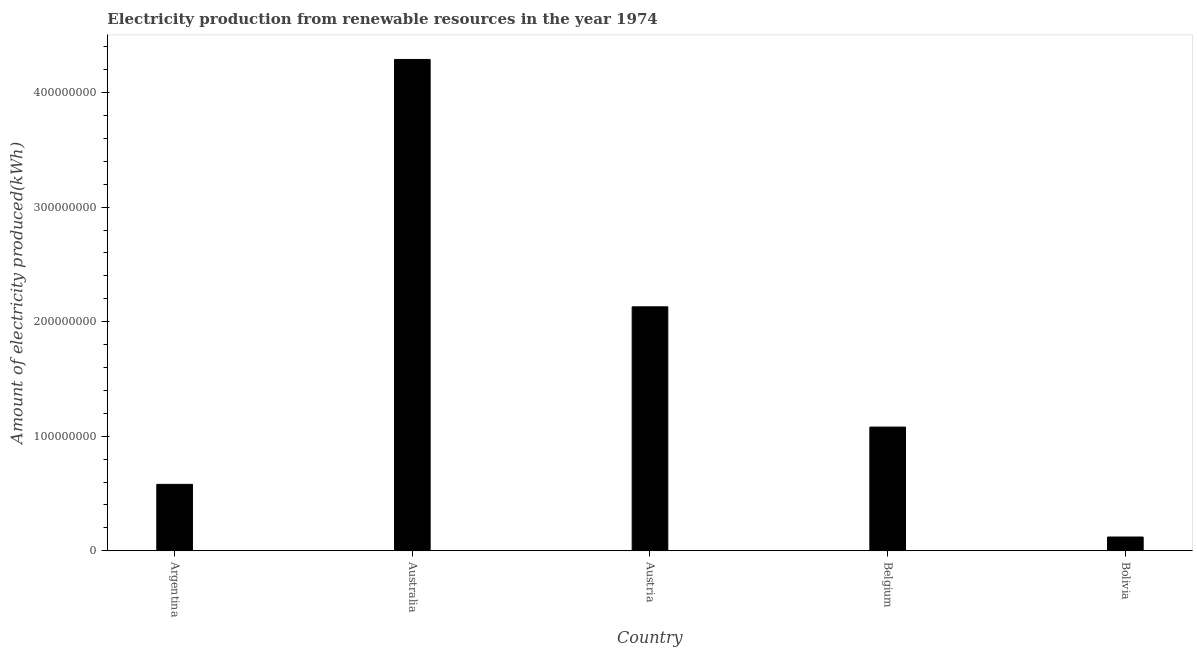Does the graph contain any zero values?
Give a very brief answer. No. Does the graph contain grids?
Keep it short and to the point. No. What is the title of the graph?
Your response must be concise. Electricity production from renewable resources in the year 1974. What is the label or title of the Y-axis?
Offer a very short reply. Amount of electricity produced(kWh). Across all countries, what is the maximum amount of electricity produced?
Keep it short and to the point. 4.29e+08. What is the sum of the amount of electricity produced?
Offer a terse response. 8.20e+08. What is the difference between the amount of electricity produced in Argentina and Belgium?
Give a very brief answer. -5.00e+07. What is the average amount of electricity produced per country?
Ensure brevity in your answer.  1.64e+08. What is the median amount of electricity produced?
Your response must be concise. 1.08e+08. What is the ratio of the amount of electricity produced in Austria to that in Belgium?
Provide a succinct answer. 1.97. Is the difference between the amount of electricity produced in Argentina and Belgium greater than the difference between any two countries?
Offer a very short reply. No. What is the difference between the highest and the second highest amount of electricity produced?
Keep it short and to the point. 2.16e+08. What is the difference between the highest and the lowest amount of electricity produced?
Your answer should be very brief. 4.17e+08. How many bars are there?
Ensure brevity in your answer.  5. How many countries are there in the graph?
Provide a short and direct response. 5. What is the Amount of electricity produced(kWh) of Argentina?
Provide a succinct answer. 5.80e+07. What is the Amount of electricity produced(kWh) of Australia?
Offer a terse response. 4.29e+08. What is the Amount of electricity produced(kWh) of Austria?
Ensure brevity in your answer.  2.13e+08. What is the Amount of electricity produced(kWh) of Belgium?
Make the answer very short. 1.08e+08. What is the difference between the Amount of electricity produced(kWh) in Argentina and Australia?
Offer a very short reply. -3.71e+08. What is the difference between the Amount of electricity produced(kWh) in Argentina and Austria?
Give a very brief answer. -1.55e+08. What is the difference between the Amount of electricity produced(kWh) in Argentina and Belgium?
Your answer should be compact. -5.00e+07. What is the difference between the Amount of electricity produced(kWh) in Argentina and Bolivia?
Ensure brevity in your answer.  4.60e+07. What is the difference between the Amount of electricity produced(kWh) in Australia and Austria?
Offer a terse response. 2.16e+08. What is the difference between the Amount of electricity produced(kWh) in Australia and Belgium?
Offer a very short reply. 3.21e+08. What is the difference between the Amount of electricity produced(kWh) in Australia and Bolivia?
Provide a short and direct response. 4.17e+08. What is the difference between the Amount of electricity produced(kWh) in Austria and Belgium?
Ensure brevity in your answer.  1.05e+08. What is the difference between the Amount of electricity produced(kWh) in Austria and Bolivia?
Keep it short and to the point. 2.01e+08. What is the difference between the Amount of electricity produced(kWh) in Belgium and Bolivia?
Make the answer very short. 9.60e+07. What is the ratio of the Amount of electricity produced(kWh) in Argentina to that in Australia?
Make the answer very short. 0.14. What is the ratio of the Amount of electricity produced(kWh) in Argentina to that in Austria?
Your answer should be compact. 0.27. What is the ratio of the Amount of electricity produced(kWh) in Argentina to that in Belgium?
Provide a succinct answer. 0.54. What is the ratio of the Amount of electricity produced(kWh) in Argentina to that in Bolivia?
Your response must be concise. 4.83. What is the ratio of the Amount of electricity produced(kWh) in Australia to that in Austria?
Offer a terse response. 2.01. What is the ratio of the Amount of electricity produced(kWh) in Australia to that in Belgium?
Make the answer very short. 3.97. What is the ratio of the Amount of electricity produced(kWh) in Australia to that in Bolivia?
Give a very brief answer. 35.75. What is the ratio of the Amount of electricity produced(kWh) in Austria to that in Belgium?
Provide a short and direct response. 1.97. What is the ratio of the Amount of electricity produced(kWh) in Austria to that in Bolivia?
Offer a terse response. 17.75. 